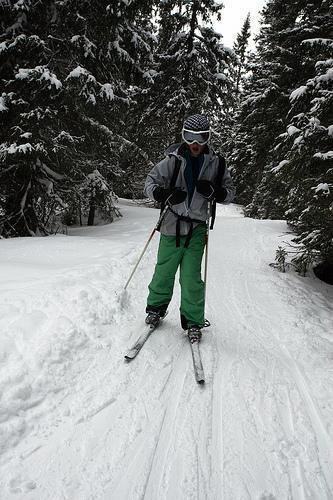How many people are there?
Give a very brief answer. 1. How many people are skiing?
Give a very brief answer. 1. How many people are wearing ski goggles?
Give a very brief answer. 1. How many children are there?
Give a very brief answer. 0. 